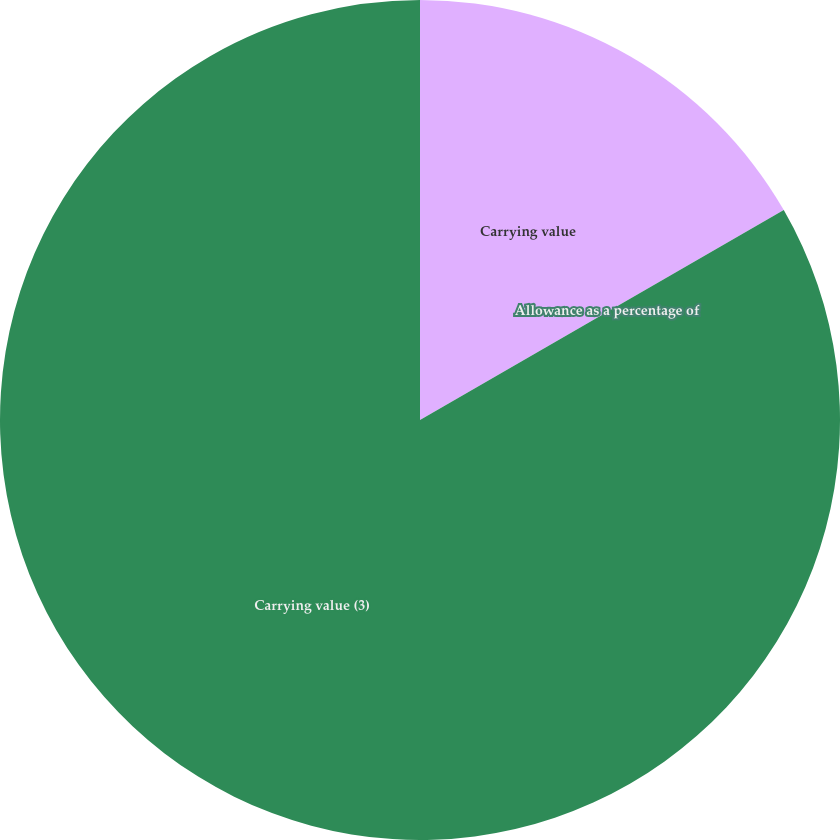Convert chart to OTSL. <chart><loc_0><loc_0><loc_500><loc_500><pie_chart><fcel>Carrying value<fcel>Allowance as a percentage of<fcel>Carrying value (3)<nl><fcel>16.67%<fcel>0.0%<fcel>83.33%<nl></chart> 